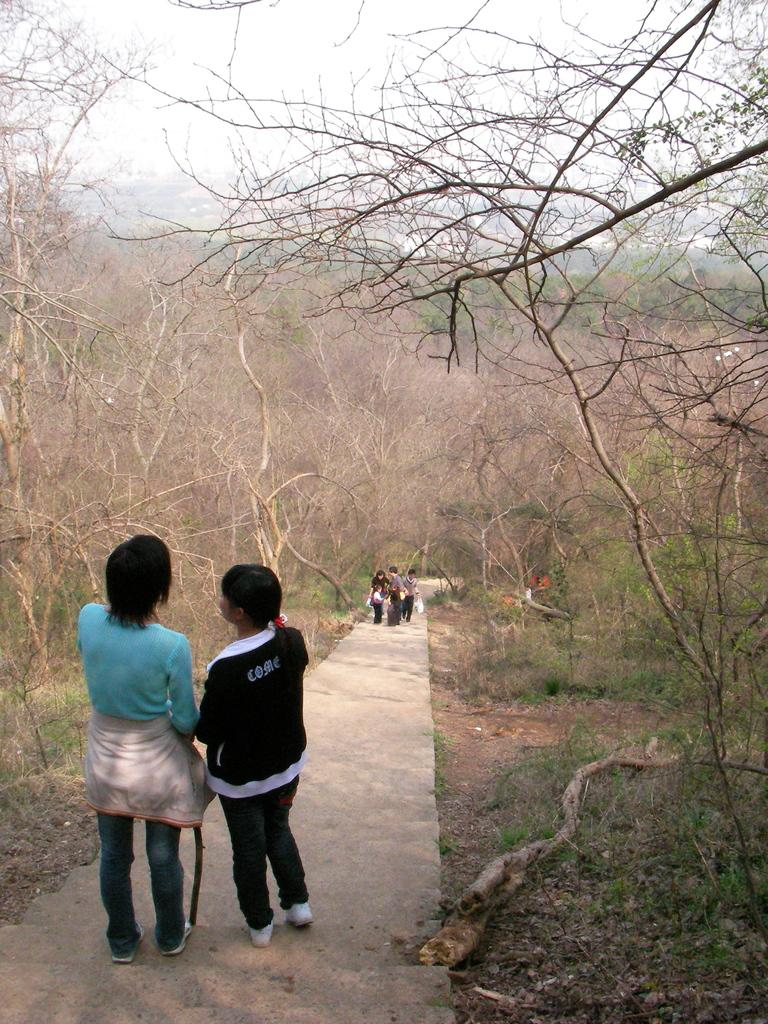What can be seen in the image? There are people standing in the image. What are the people wearing? The people are wearing clothes and shoes. What type of vegetation is present in the image? There are dry trees and grass in the image. Is there any man-made structure visible in the image? Yes, there is a path in the image. What is visible in the background of the image? The sky is visible in the image. What type of butter is being spread on the brother's head in the image? There is no butter or brother present in the image; it only features people standing, dry trees, grass, a path, and the sky. 